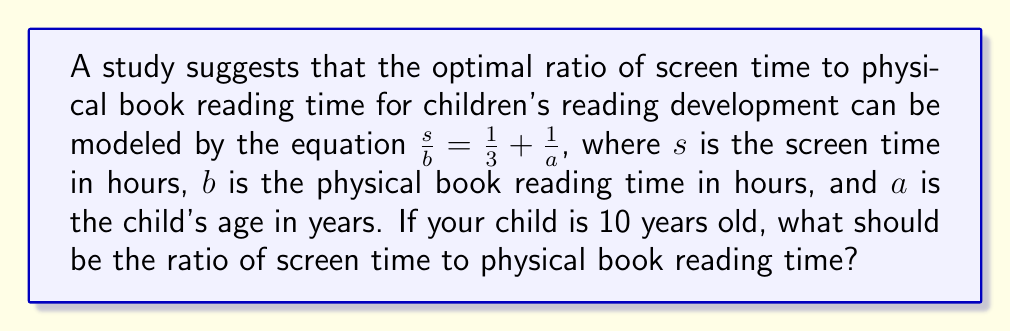What is the answer to this math problem? 1. We are given the equation: $\frac{s}{b} = \frac{1}{3} + \frac{1}{a}$

2. We know that the child's age, $a$, is 10 years old.

3. Let's substitute $a = 10$ into the equation:
   $\frac{s}{b} = \frac{1}{3} + \frac{1}{10}$

4. Now, we need to simplify the right side of the equation:
   $\frac{1}{3} + \frac{1}{10} = \frac{10}{30} + \frac{3}{30} = \frac{13}{30}$

5. Therefore, the optimal ratio of screen time to physical book reading time is:
   $\frac{s}{b} = \frac{13}{30}$

This means that for every 30 minutes of total reading time, 13 minutes should be screen time and 17 minutes should be physical book reading time.
Answer: $\frac{13}{30}$ 